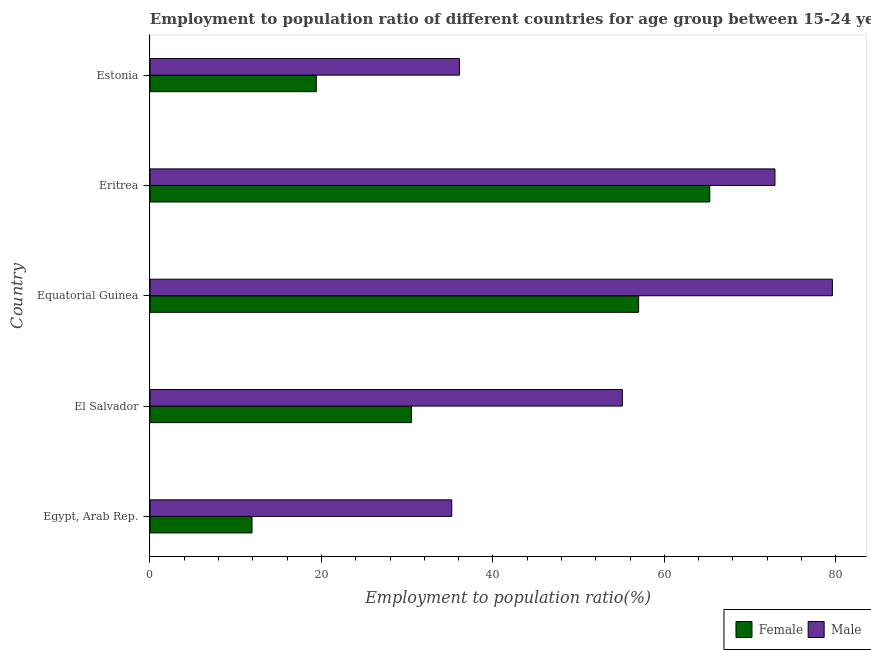Are the number of bars per tick equal to the number of legend labels?
Offer a terse response. Yes. Are the number of bars on each tick of the Y-axis equal?
Provide a short and direct response. Yes. What is the label of the 3rd group of bars from the top?
Offer a terse response. Equatorial Guinea. In how many cases, is the number of bars for a given country not equal to the number of legend labels?
Provide a short and direct response. 0. What is the employment to population ratio(male) in Eritrea?
Give a very brief answer. 72.9. Across all countries, what is the maximum employment to population ratio(male)?
Provide a succinct answer. 79.6. Across all countries, what is the minimum employment to population ratio(male)?
Provide a short and direct response. 35.2. In which country was the employment to population ratio(female) maximum?
Provide a short and direct response. Eritrea. In which country was the employment to population ratio(female) minimum?
Your answer should be very brief. Egypt, Arab Rep. What is the total employment to population ratio(female) in the graph?
Offer a terse response. 184.1. What is the difference between the employment to population ratio(male) in El Salvador and that in Eritrea?
Your answer should be compact. -17.8. What is the difference between the employment to population ratio(female) in Equatorial Guinea and the employment to population ratio(male) in El Salvador?
Your answer should be compact. 1.9. What is the average employment to population ratio(female) per country?
Provide a succinct answer. 36.82. What is the difference between the employment to population ratio(male) and employment to population ratio(female) in Egypt, Arab Rep.?
Provide a succinct answer. 23.3. What is the ratio of the employment to population ratio(female) in Egypt, Arab Rep. to that in El Salvador?
Your response must be concise. 0.39. Is the difference between the employment to population ratio(male) in El Salvador and Eritrea greater than the difference between the employment to population ratio(female) in El Salvador and Eritrea?
Your answer should be very brief. Yes. What is the difference between the highest and the lowest employment to population ratio(female)?
Give a very brief answer. 53.4. Is the sum of the employment to population ratio(male) in Egypt, Arab Rep. and Equatorial Guinea greater than the maximum employment to population ratio(female) across all countries?
Offer a very short reply. Yes. What does the 2nd bar from the bottom in Estonia represents?
Give a very brief answer. Male. Are all the bars in the graph horizontal?
Keep it short and to the point. Yes. What is the difference between two consecutive major ticks on the X-axis?
Provide a short and direct response. 20. Does the graph contain any zero values?
Your answer should be compact. No. Where does the legend appear in the graph?
Give a very brief answer. Bottom right. How many legend labels are there?
Provide a succinct answer. 2. What is the title of the graph?
Make the answer very short. Employment to population ratio of different countries for age group between 15-24 years. What is the label or title of the X-axis?
Your response must be concise. Employment to population ratio(%). What is the Employment to population ratio(%) in Female in Egypt, Arab Rep.?
Offer a terse response. 11.9. What is the Employment to population ratio(%) of Male in Egypt, Arab Rep.?
Ensure brevity in your answer.  35.2. What is the Employment to population ratio(%) of Female in El Salvador?
Ensure brevity in your answer.  30.5. What is the Employment to population ratio(%) in Male in El Salvador?
Offer a terse response. 55.1. What is the Employment to population ratio(%) in Female in Equatorial Guinea?
Your answer should be compact. 57. What is the Employment to population ratio(%) of Male in Equatorial Guinea?
Provide a short and direct response. 79.6. What is the Employment to population ratio(%) in Female in Eritrea?
Make the answer very short. 65.3. What is the Employment to population ratio(%) in Male in Eritrea?
Ensure brevity in your answer.  72.9. What is the Employment to population ratio(%) of Female in Estonia?
Your answer should be very brief. 19.4. What is the Employment to population ratio(%) of Male in Estonia?
Make the answer very short. 36.1. Across all countries, what is the maximum Employment to population ratio(%) of Female?
Keep it short and to the point. 65.3. Across all countries, what is the maximum Employment to population ratio(%) in Male?
Your answer should be compact. 79.6. Across all countries, what is the minimum Employment to population ratio(%) in Female?
Offer a terse response. 11.9. Across all countries, what is the minimum Employment to population ratio(%) of Male?
Offer a very short reply. 35.2. What is the total Employment to population ratio(%) in Female in the graph?
Your response must be concise. 184.1. What is the total Employment to population ratio(%) of Male in the graph?
Offer a very short reply. 278.9. What is the difference between the Employment to population ratio(%) in Female in Egypt, Arab Rep. and that in El Salvador?
Provide a short and direct response. -18.6. What is the difference between the Employment to population ratio(%) of Male in Egypt, Arab Rep. and that in El Salvador?
Provide a short and direct response. -19.9. What is the difference between the Employment to population ratio(%) in Female in Egypt, Arab Rep. and that in Equatorial Guinea?
Make the answer very short. -45.1. What is the difference between the Employment to population ratio(%) of Male in Egypt, Arab Rep. and that in Equatorial Guinea?
Provide a short and direct response. -44.4. What is the difference between the Employment to population ratio(%) in Female in Egypt, Arab Rep. and that in Eritrea?
Your response must be concise. -53.4. What is the difference between the Employment to population ratio(%) of Male in Egypt, Arab Rep. and that in Eritrea?
Your answer should be very brief. -37.7. What is the difference between the Employment to population ratio(%) in Male in Egypt, Arab Rep. and that in Estonia?
Make the answer very short. -0.9. What is the difference between the Employment to population ratio(%) of Female in El Salvador and that in Equatorial Guinea?
Provide a succinct answer. -26.5. What is the difference between the Employment to population ratio(%) of Male in El Salvador and that in Equatorial Guinea?
Ensure brevity in your answer.  -24.5. What is the difference between the Employment to population ratio(%) of Female in El Salvador and that in Eritrea?
Your answer should be very brief. -34.8. What is the difference between the Employment to population ratio(%) of Male in El Salvador and that in Eritrea?
Provide a short and direct response. -17.8. What is the difference between the Employment to population ratio(%) in Male in El Salvador and that in Estonia?
Give a very brief answer. 19. What is the difference between the Employment to population ratio(%) in Female in Equatorial Guinea and that in Eritrea?
Give a very brief answer. -8.3. What is the difference between the Employment to population ratio(%) in Female in Equatorial Guinea and that in Estonia?
Provide a succinct answer. 37.6. What is the difference between the Employment to population ratio(%) of Male in Equatorial Guinea and that in Estonia?
Your answer should be very brief. 43.5. What is the difference between the Employment to population ratio(%) of Female in Eritrea and that in Estonia?
Offer a terse response. 45.9. What is the difference between the Employment to population ratio(%) in Male in Eritrea and that in Estonia?
Give a very brief answer. 36.8. What is the difference between the Employment to population ratio(%) in Female in Egypt, Arab Rep. and the Employment to population ratio(%) in Male in El Salvador?
Provide a short and direct response. -43.2. What is the difference between the Employment to population ratio(%) of Female in Egypt, Arab Rep. and the Employment to population ratio(%) of Male in Equatorial Guinea?
Your answer should be very brief. -67.7. What is the difference between the Employment to population ratio(%) in Female in Egypt, Arab Rep. and the Employment to population ratio(%) in Male in Eritrea?
Your answer should be very brief. -61. What is the difference between the Employment to population ratio(%) in Female in Egypt, Arab Rep. and the Employment to population ratio(%) in Male in Estonia?
Make the answer very short. -24.2. What is the difference between the Employment to population ratio(%) in Female in El Salvador and the Employment to population ratio(%) in Male in Equatorial Guinea?
Make the answer very short. -49.1. What is the difference between the Employment to population ratio(%) of Female in El Salvador and the Employment to population ratio(%) of Male in Eritrea?
Keep it short and to the point. -42.4. What is the difference between the Employment to population ratio(%) in Female in El Salvador and the Employment to population ratio(%) in Male in Estonia?
Your answer should be very brief. -5.6. What is the difference between the Employment to population ratio(%) in Female in Equatorial Guinea and the Employment to population ratio(%) in Male in Eritrea?
Keep it short and to the point. -15.9. What is the difference between the Employment to population ratio(%) of Female in Equatorial Guinea and the Employment to population ratio(%) of Male in Estonia?
Give a very brief answer. 20.9. What is the difference between the Employment to population ratio(%) of Female in Eritrea and the Employment to population ratio(%) of Male in Estonia?
Keep it short and to the point. 29.2. What is the average Employment to population ratio(%) of Female per country?
Ensure brevity in your answer.  36.82. What is the average Employment to population ratio(%) of Male per country?
Provide a succinct answer. 55.78. What is the difference between the Employment to population ratio(%) in Female and Employment to population ratio(%) in Male in Egypt, Arab Rep.?
Provide a succinct answer. -23.3. What is the difference between the Employment to population ratio(%) of Female and Employment to population ratio(%) of Male in El Salvador?
Your response must be concise. -24.6. What is the difference between the Employment to population ratio(%) of Female and Employment to population ratio(%) of Male in Equatorial Guinea?
Your response must be concise. -22.6. What is the difference between the Employment to population ratio(%) of Female and Employment to population ratio(%) of Male in Estonia?
Provide a short and direct response. -16.7. What is the ratio of the Employment to population ratio(%) of Female in Egypt, Arab Rep. to that in El Salvador?
Provide a succinct answer. 0.39. What is the ratio of the Employment to population ratio(%) of Male in Egypt, Arab Rep. to that in El Salvador?
Keep it short and to the point. 0.64. What is the ratio of the Employment to population ratio(%) of Female in Egypt, Arab Rep. to that in Equatorial Guinea?
Make the answer very short. 0.21. What is the ratio of the Employment to population ratio(%) of Male in Egypt, Arab Rep. to that in Equatorial Guinea?
Your answer should be very brief. 0.44. What is the ratio of the Employment to population ratio(%) in Female in Egypt, Arab Rep. to that in Eritrea?
Ensure brevity in your answer.  0.18. What is the ratio of the Employment to population ratio(%) in Male in Egypt, Arab Rep. to that in Eritrea?
Offer a very short reply. 0.48. What is the ratio of the Employment to population ratio(%) of Female in Egypt, Arab Rep. to that in Estonia?
Your answer should be very brief. 0.61. What is the ratio of the Employment to population ratio(%) of Male in Egypt, Arab Rep. to that in Estonia?
Keep it short and to the point. 0.98. What is the ratio of the Employment to population ratio(%) in Female in El Salvador to that in Equatorial Guinea?
Provide a succinct answer. 0.54. What is the ratio of the Employment to population ratio(%) of Male in El Salvador to that in Equatorial Guinea?
Provide a succinct answer. 0.69. What is the ratio of the Employment to population ratio(%) of Female in El Salvador to that in Eritrea?
Offer a very short reply. 0.47. What is the ratio of the Employment to population ratio(%) of Male in El Salvador to that in Eritrea?
Keep it short and to the point. 0.76. What is the ratio of the Employment to population ratio(%) of Female in El Salvador to that in Estonia?
Offer a very short reply. 1.57. What is the ratio of the Employment to population ratio(%) of Male in El Salvador to that in Estonia?
Your answer should be compact. 1.53. What is the ratio of the Employment to population ratio(%) of Female in Equatorial Guinea to that in Eritrea?
Your answer should be very brief. 0.87. What is the ratio of the Employment to population ratio(%) in Male in Equatorial Guinea to that in Eritrea?
Provide a succinct answer. 1.09. What is the ratio of the Employment to population ratio(%) in Female in Equatorial Guinea to that in Estonia?
Give a very brief answer. 2.94. What is the ratio of the Employment to population ratio(%) of Male in Equatorial Guinea to that in Estonia?
Make the answer very short. 2.21. What is the ratio of the Employment to population ratio(%) of Female in Eritrea to that in Estonia?
Give a very brief answer. 3.37. What is the ratio of the Employment to population ratio(%) in Male in Eritrea to that in Estonia?
Make the answer very short. 2.02. What is the difference between the highest and the second highest Employment to population ratio(%) in Female?
Make the answer very short. 8.3. What is the difference between the highest and the lowest Employment to population ratio(%) in Female?
Provide a succinct answer. 53.4. What is the difference between the highest and the lowest Employment to population ratio(%) in Male?
Ensure brevity in your answer.  44.4. 